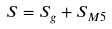Convert formula to latex. <formula><loc_0><loc_0><loc_500><loc_500>S = S _ { g } + S _ { M 5 }</formula> 